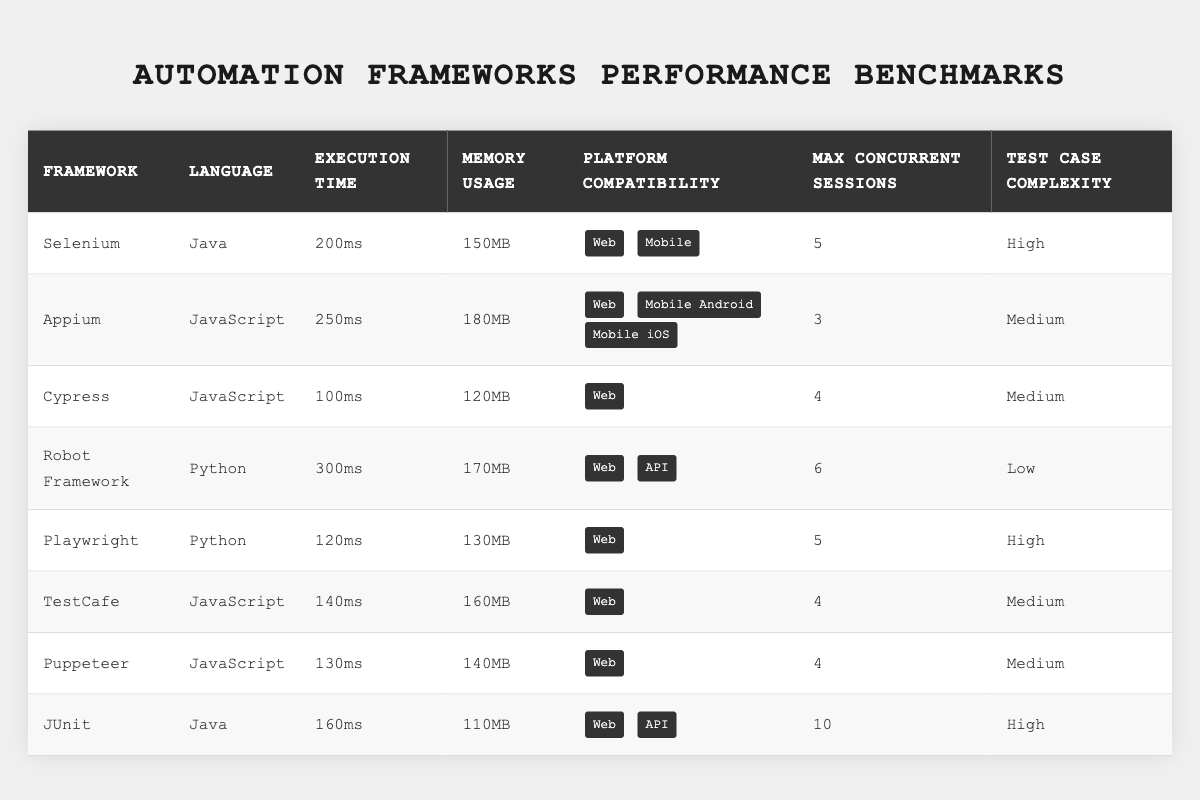What is the execution time of Cypress? To find the execution time of Cypress, look for the row in the table corresponding to Cypress. The execution time listed in that row is 100ms.
Answer: 100ms Which framework has the highest memory usage? Review the memory usage column and observe the values for each framework. Robot Framework has a memory usage of 170MB, which is the highest.
Answer: Robot Framework What is the maximum number of concurrent sessions for JUnit? Locate the row for JUnit in the table, then check the max concurrent sessions column. JUnit has a maximum of 10 concurrent sessions.
Answer: 10 How does Playwright's execution time compare to Selenium's? Look at the execution time for both Playwright and Selenium. Playwright's execution time is 120ms, while Selenium's is 200ms. Therefore, Playwright is faster than Selenium.
Answer: Playwright is faster Which frameworks are compatible with both Web and API platforms? Check the platform compatibility column for each framework in the table and find those that list both Web and API. Both JUnit and Robot Framework are compatible with these platforms.
Answer: JUnit and Robot Framework What is the average execution time of all frameworks? First, sum the execution times: 200ms + 250ms + 100ms + 300ms + 120ms + 140ms + 130ms + 160ms = 1400ms. There are 8 frameworks, so the average execution time is 1400ms / 8 = 175ms.
Answer: 175ms Is Puppeteer the lightest framework in terms of memory usage? Compare the memory usage of Puppeteer, which is 140MB, with the other frameworks' memory usages. Puppeteer is not the lightest; JUnit has the lowest memory usage at 110MB.
Answer: No Between Selenium and Appium, which has a lower test case complexity? Look at the test case complexity for both frameworks. Selenium has 'High' complexity, and Appium has 'Medium' complexity. Since Medium is lower than High, Appium has a lower test case complexity.
Answer: Appium Which framework supports the least number of concurrent sessions? Examine the max concurrent sessions for each framework. Appium has the least with 3 concurrent sessions.
Answer: Appium Is it true that Cypress has a higher execution time than TestCafe? Compare the execution times: Cypress is 100ms and TestCafe is 140ms. Since 100ms is less than 140ms, the statement is false.
Answer: False How many frameworks are compatible exclusively with Web? Review the platform compatibility for each framework and count those that only list Web. Cypress, TestCafe, and Puppeteer are the only ones that are compatible exclusively with Web, totaling 3.
Answer: 3 